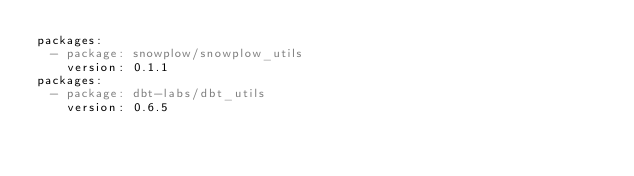<code> <loc_0><loc_0><loc_500><loc_500><_YAML_>packages:
  - package: snowplow/snowplow_utils
    version: 0.1.1
packages:
  - package: dbt-labs/dbt_utils
    version: 0.6.5</code> 